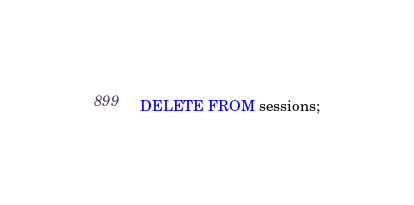Convert code to text. <code><loc_0><loc_0><loc_500><loc_500><_SQL_>DELETE FROM sessions;</code> 